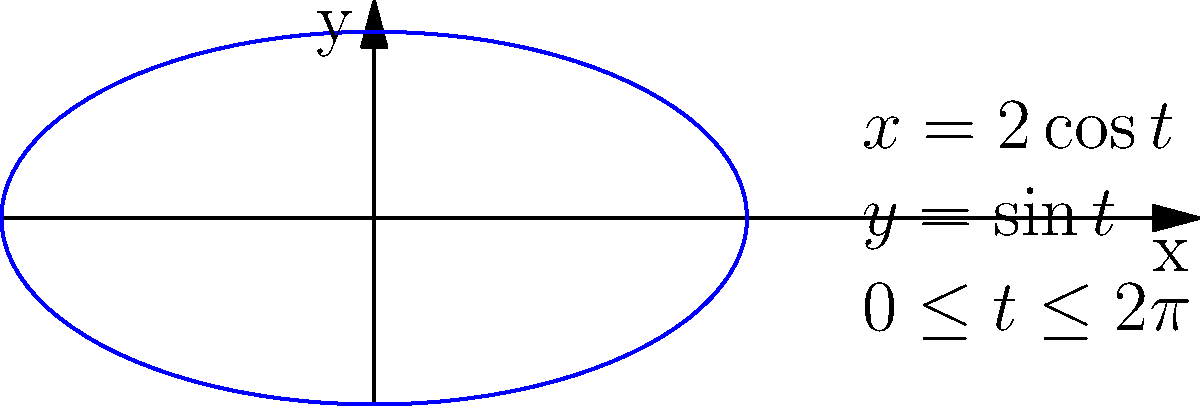Consider the parametric curve given by $x = 2\cos t$ and $y = \sin t$ for $0 \leq t \leq 2\pi$, as shown in the figure. Calculate the arc length of this curve. To find the arc length of a parametric curve, we use the formula:

$$L = \int_a^b \sqrt{\left(\frac{dx}{dt}\right)^2 + \left(\frac{dy}{dt}\right)^2} dt$$

Step 1: Find $\frac{dx}{dt}$ and $\frac{dy}{dt}$
$$\frac{dx}{dt} = -2\sin t$$
$$\frac{dy}{dt} = \cos t$$

Step 2: Substitute into the arc length formula
$$L = \int_0^{2\pi} \sqrt{(-2\sin t)^2 + (\cos t)^2} dt$$

Step 3: Simplify under the square root
$$L = \int_0^{2\pi} \sqrt{4\sin^2 t + \cos^2 t} dt$$

Step 4: Use the trigonometric identity $\sin^2 t + \cos^2 t = 1$
$$L = \int_0^{2\pi} \sqrt{4\sin^2 t + \cos^2 t} dt = \int_0^{2\pi} \sqrt{3\sin^2 t + 1} dt$$

Step 5: Let $u = \sin t$, then $du = \cos t dt$ and $dt = \frac{du}{\cos t}$
When $t = 0$, $u = 0$; when $t = 2\pi$, $u = 0$

$$L = \int_0^0 \sqrt{3u^2 + 1} \frac{du}{\cos t} = 2\int_0^1 \sqrt{3u^2 + 1} du$$

Step 6: This integral doesn't have an elementary antiderivative. It can be expressed in terms of elliptic integrals or evaluated numerically.

Using numerical integration, we get:

$$L \approx 7.64$$
Answer: $7.64$ (approximately) 